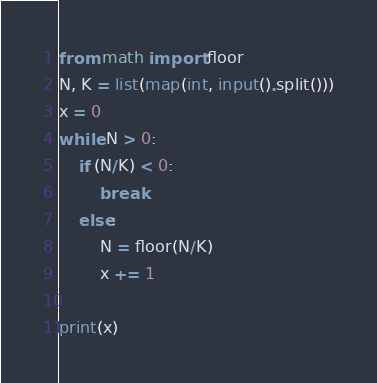<code> <loc_0><loc_0><loc_500><loc_500><_Python_>from math import floor
N, K = list(map(int, input().split()))
x = 0
while N > 0:
    if (N/K) < 0:
        break
    else:
        N = floor(N/K)
        x += 1

print(x)</code> 